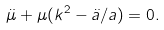<formula> <loc_0><loc_0><loc_500><loc_500>\ddot { \mu } + \mu ( k ^ { 2 } - \ddot { a } / a ) = 0 .</formula> 